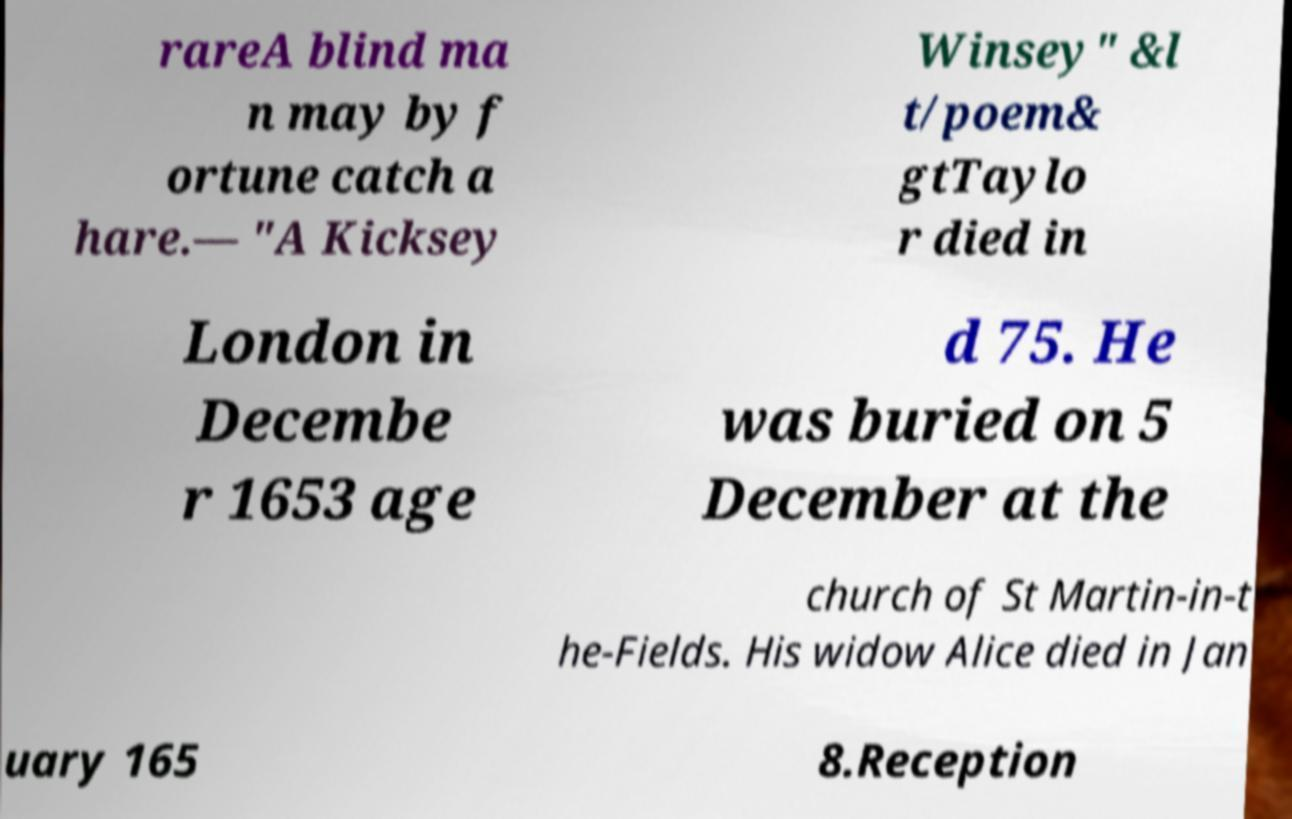I need the written content from this picture converted into text. Can you do that? rareA blind ma n may by f ortune catch a hare.— "A Kicksey Winsey" &l t/poem& gtTaylo r died in London in Decembe r 1653 age d 75. He was buried on 5 December at the church of St Martin-in-t he-Fields. His widow Alice died in Jan uary 165 8.Reception 